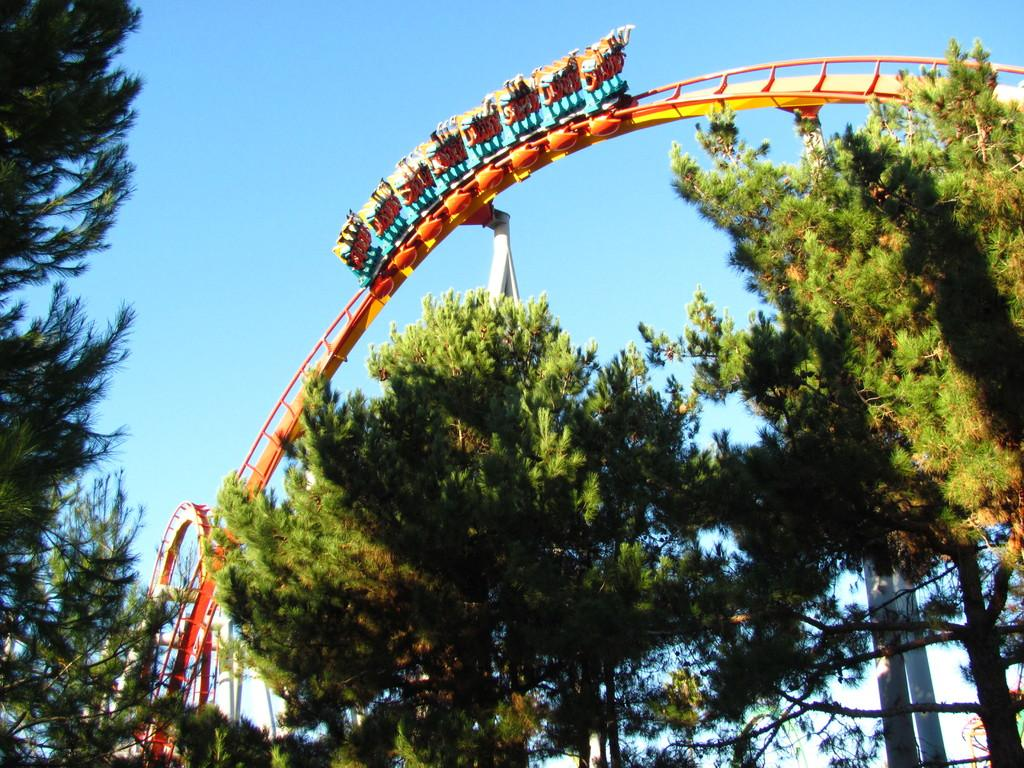What is the main subject of the image? There is a roller coaster in the image. What else can be seen in the image besides the roller coaster? There are many trees in the image. What is visible in the background of the image? The sky is visible in the background of the image. What type of knot is being used to secure the roller coaster in the image? There is no knot visible in the image, as the roller coaster is a large structure and not secured with a knot. 